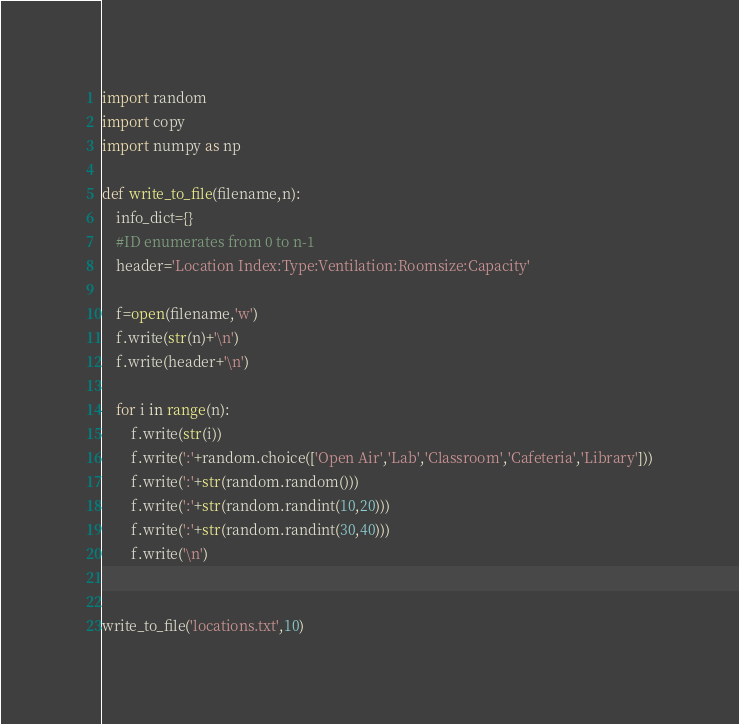Convert code to text. <code><loc_0><loc_0><loc_500><loc_500><_Python_>import random
import copy
import numpy as np

def write_to_file(filename,n):
	info_dict={}
	#ID enumerates from 0 to n-1
	header='Location Index:Type:Ventilation:Roomsize:Capacity'

	f=open(filename,'w')
	f.write(str(n)+'\n')
	f.write(header+'\n')

	for i in range(n):
		f.write(str(i))
		f.write(':'+random.choice(['Open Air','Lab','Classroom','Cafeteria','Library']))
		f.write(':'+str(random.random()))
		f.write(':'+str(random.randint(10,20)))
		f.write(':'+str(random.randint(30,40)))
		f.write('\n')


write_to_file('locations.txt',10)
</code> 